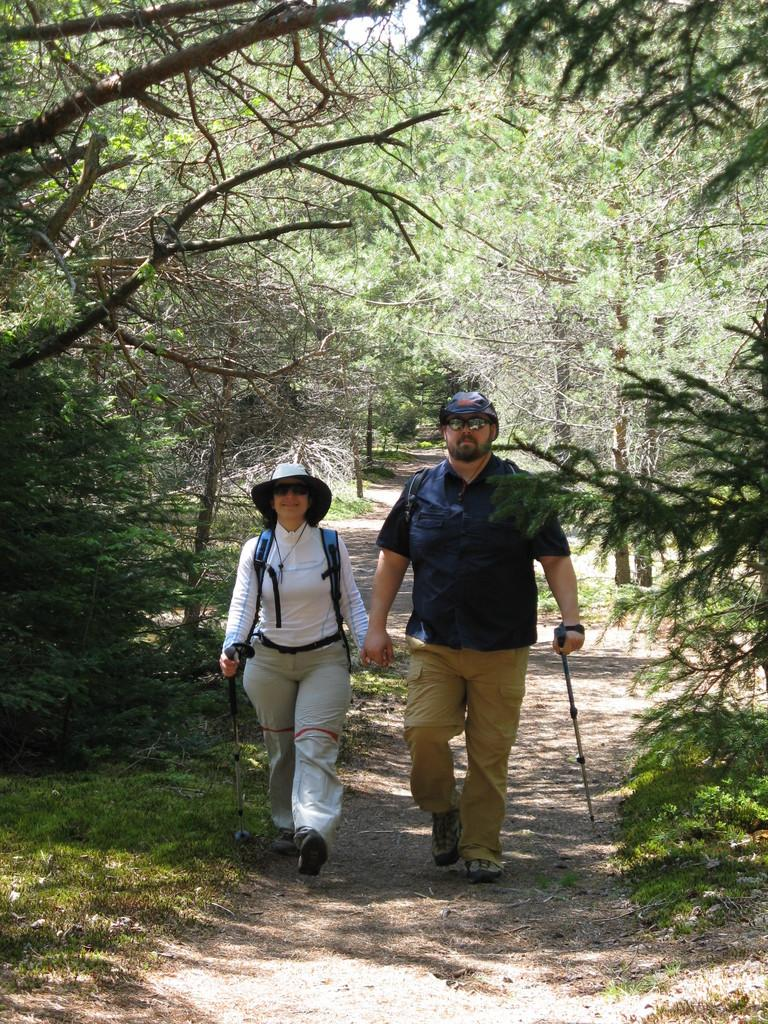How many people are present in the image? There are two people in the image. What are the two people doing in the image? The two people are walking. What can be seen in the background of the image? There are trees and the sky visible in the background of the image. What type of harmony is being performed by the people in the image? There is no indication of any performance or harmony in the image, as it simply shows two people walking. 